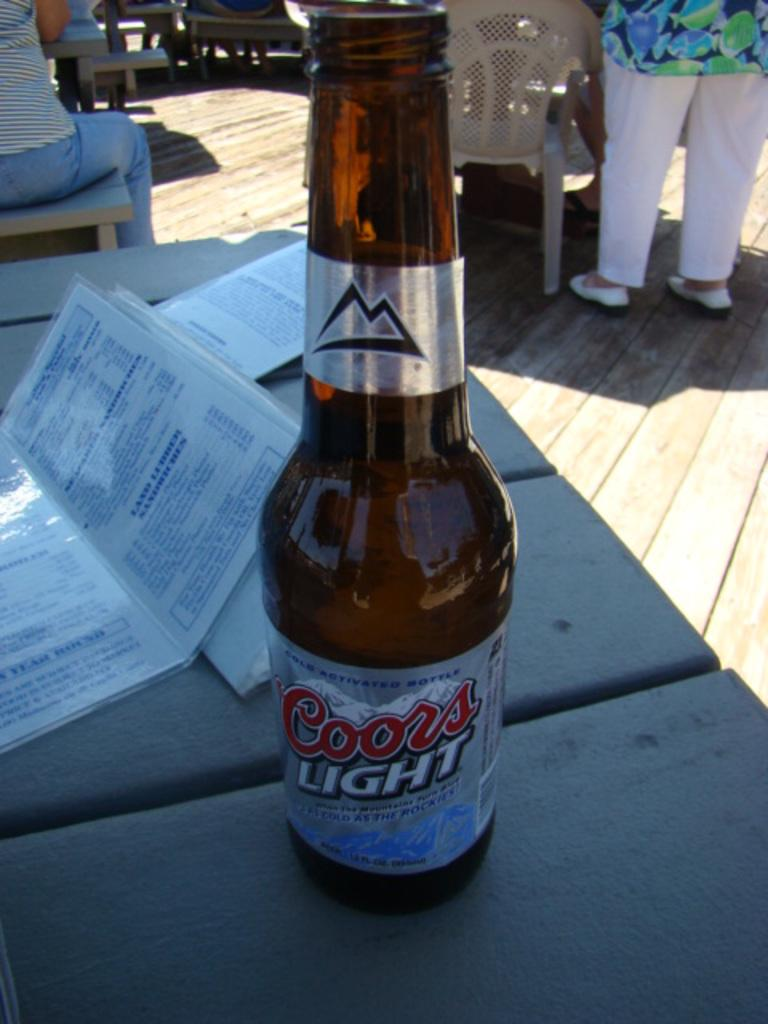What is present on the table in the image? There is a table in the image, and on it, there are menu cards and a bottle. What might the person standing near the table be doing? The person standing to the right side of the table might be looking at the menu cards or waiting for someone. What is the lighting condition in the image? There is a lot of sunlight in the image. What type of stick can be seen in the image? There is no stick present in the image. What stage of development is the boot going through in the image? There is no boot present in the image. 